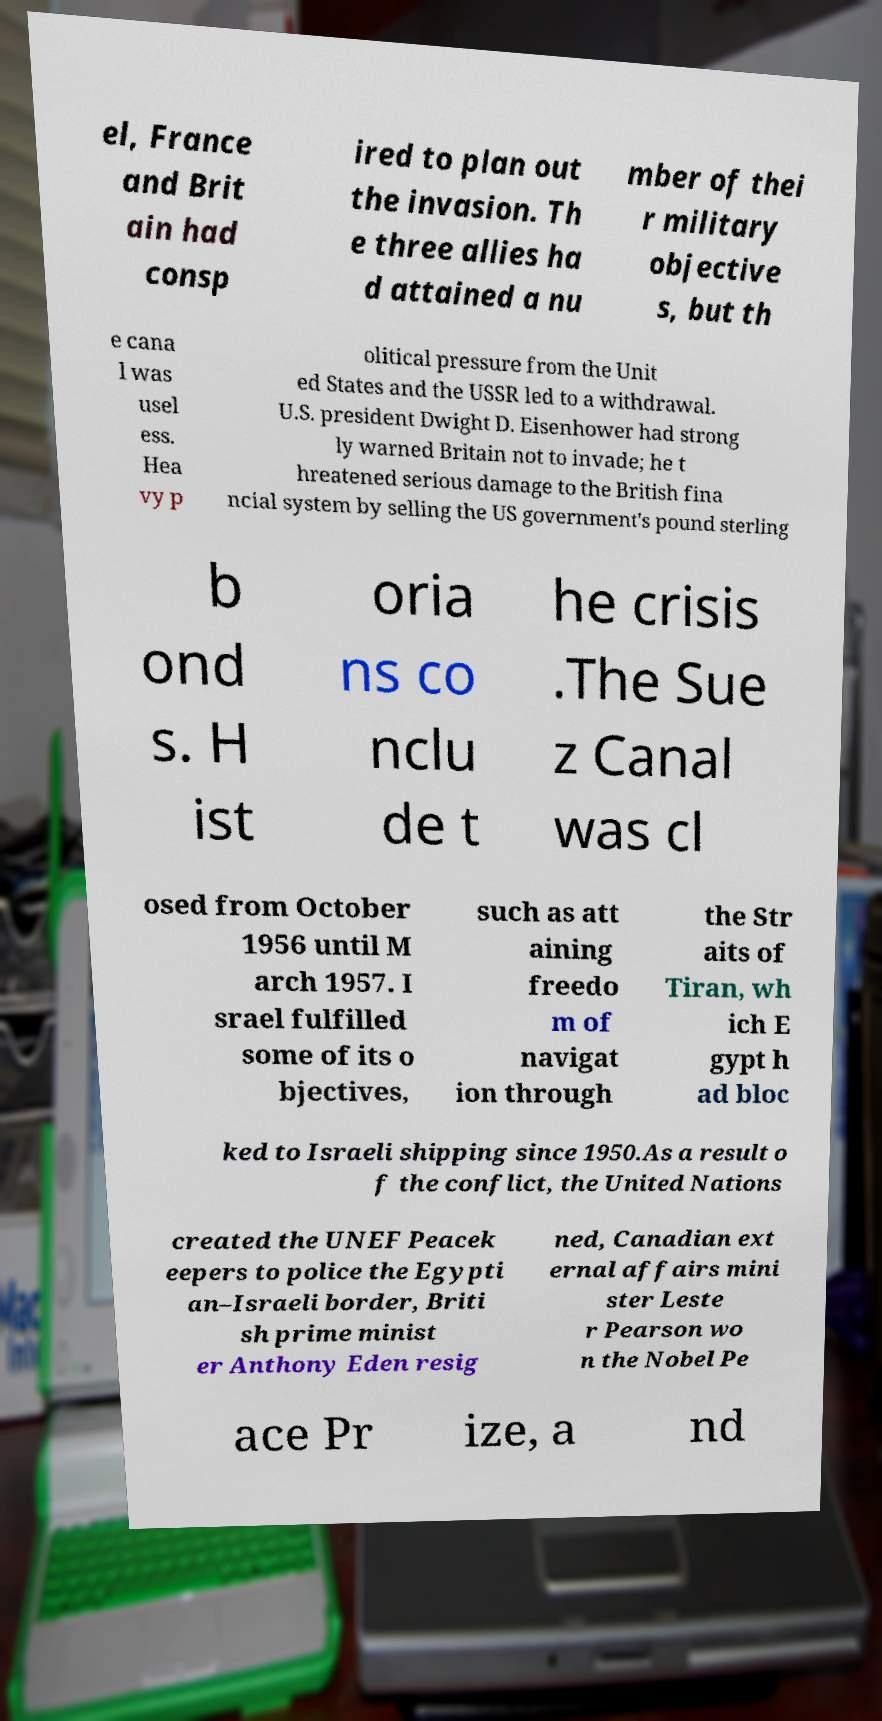There's text embedded in this image that I need extracted. Can you transcribe it verbatim? el, France and Brit ain had consp ired to plan out the invasion. Th e three allies ha d attained a nu mber of thei r military objective s, but th e cana l was usel ess. Hea vy p olitical pressure from the Unit ed States and the USSR led to a withdrawal. U.S. president Dwight D. Eisenhower had strong ly warned Britain not to invade; he t hreatened serious damage to the British fina ncial system by selling the US government's pound sterling b ond s. H ist oria ns co nclu de t he crisis .The Sue z Canal was cl osed from October 1956 until M arch 1957. I srael fulfilled some of its o bjectives, such as att aining freedo m of navigat ion through the Str aits of Tiran, wh ich E gypt h ad bloc ked to Israeli shipping since 1950.As a result o f the conflict, the United Nations created the UNEF Peacek eepers to police the Egypti an–Israeli border, Briti sh prime minist er Anthony Eden resig ned, Canadian ext ernal affairs mini ster Leste r Pearson wo n the Nobel Pe ace Pr ize, a nd 